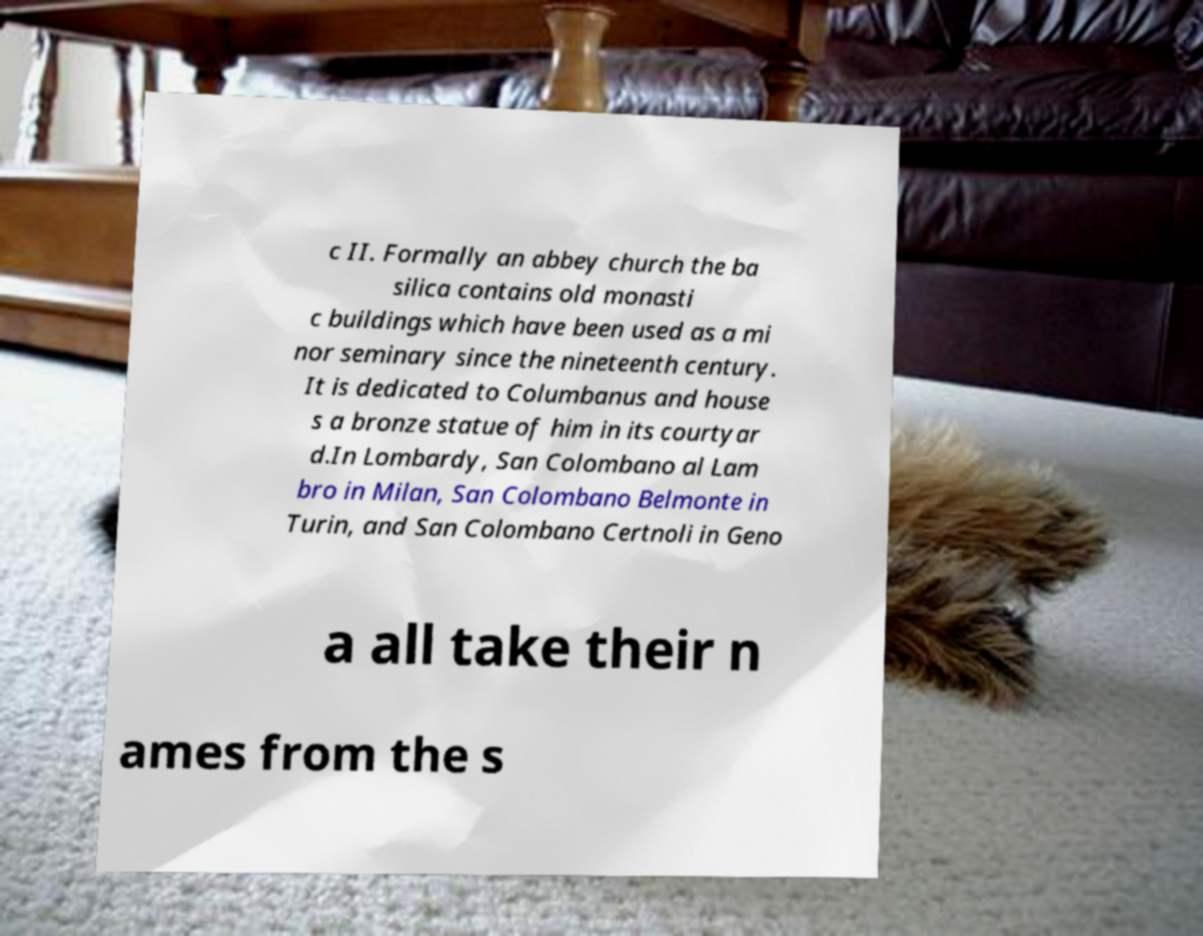Can you read and provide the text displayed in the image?This photo seems to have some interesting text. Can you extract and type it out for me? c II. Formally an abbey church the ba silica contains old monasti c buildings which have been used as a mi nor seminary since the nineteenth century. It is dedicated to Columbanus and house s a bronze statue of him in its courtyar d.In Lombardy, San Colombano al Lam bro in Milan, San Colombano Belmonte in Turin, and San Colombano Certnoli in Geno a all take their n ames from the s 